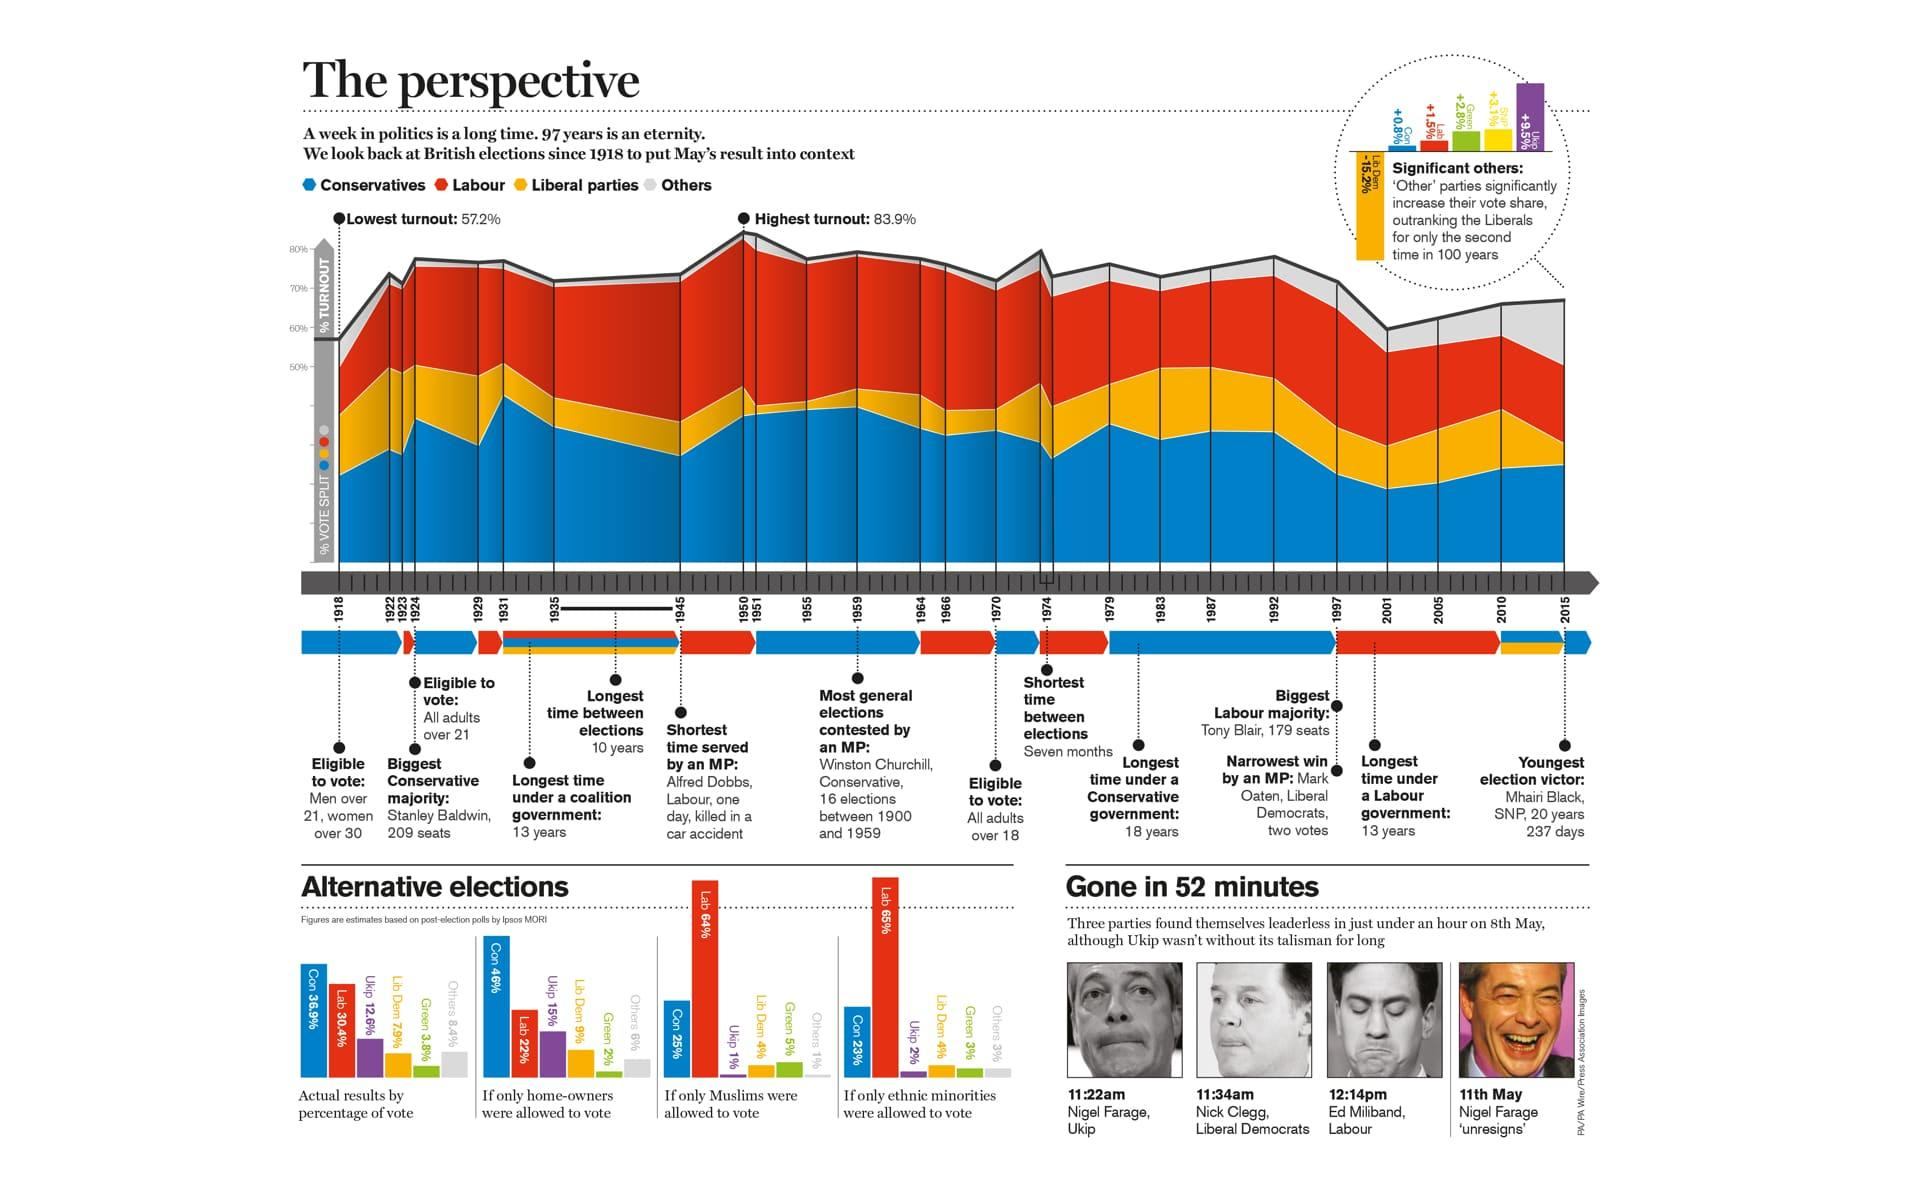Mention a couple of crucial points in this snapshot. If only ethnic minorities were allowed to vote in the UK, it is estimated that the Labour party would have received approximately 65% of the votes. The shortest time between elections in the UK since 1918 was seven months. Under a Labour government in the UK, the longest duration was 13 years. A recent estimate suggests that if only homeowners were allowed to vote in the UK, the Conservative party would likely receive 46% of the votes. If only Muslims were allowed to vote in the UK, it is estimated that the Conservative party would receive approximately 25% of the votes. 